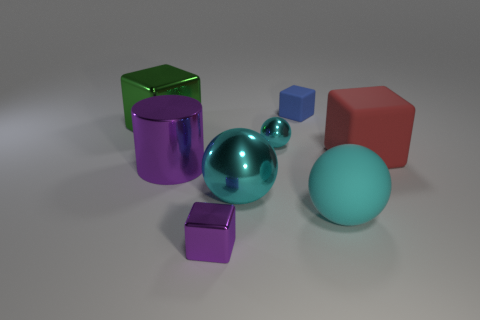There is another metallic cube that is the same size as the red cube; what is its color?
Provide a succinct answer. Green. Do the tiny thing that is behind the small cyan shiny sphere and the big green cube have the same material?
Give a very brief answer. No. There is a green metal thing on the left side of the purple thing in front of the cyan matte thing; are there any small things to the right of it?
Provide a short and direct response. Yes. There is a big shiny thing right of the small purple metal object; is it the same shape as the big red matte object?
Keep it short and to the point. No. The large matte thing behind the shiny cylinder in front of the big red block is what shape?
Provide a short and direct response. Cube. There is a purple thing that is on the left side of the purple shiny object in front of the rubber thing that is in front of the big cylinder; how big is it?
Offer a terse response. Large. What is the color of the other matte object that is the same shape as the tiny blue matte object?
Your answer should be very brief. Red. Do the purple cylinder and the purple metal block have the same size?
Provide a short and direct response. No. There is a small purple object in front of the blue cube; what is it made of?
Offer a terse response. Metal. How many other things are there of the same shape as the tiny purple metallic thing?
Your answer should be very brief. 3. 